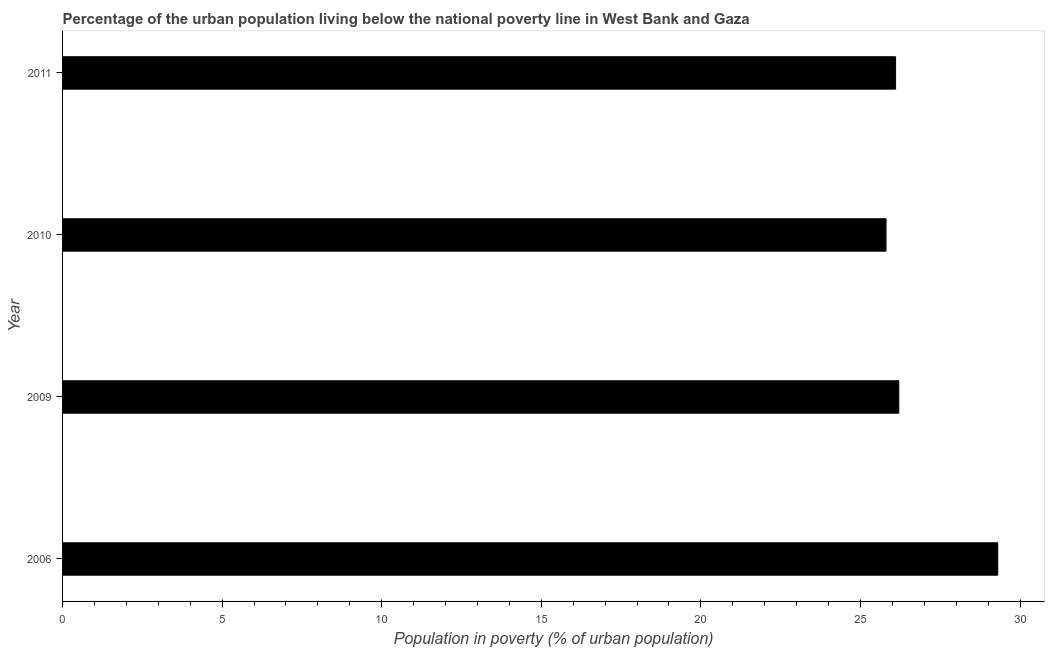Does the graph contain any zero values?
Offer a terse response. No. Does the graph contain grids?
Your answer should be compact. No. What is the title of the graph?
Your response must be concise. Percentage of the urban population living below the national poverty line in West Bank and Gaza. What is the label or title of the X-axis?
Give a very brief answer. Population in poverty (% of urban population). What is the label or title of the Y-axis?
Make the answer very short. Year. What is the percentage of urban population living below poverty line in 2009?
Provide a succinct answer. 26.2. Across all years, what is the maximum percentage of urban population living below poverty line?
Make the answer very short. 29.3. Across all years, what is the minimum percentage of urban population living below poverty line?
Your answer should be compact. 25.8. In which year was the percentage of urban population living below poverty line minimum?
Make the answer very short. 2010. What is the sum of the percentage of urban population living below poverty line?
Your answer should be compact. 107.4. What is the difference between the percentage of urban population living below poverty line in 2010 and 2011?
Provide a succinct answer. -0.3. What is the average percentage of urban population living below poverty line per year?
Give a very brief answer. 26.85. What is the median percentage of urban population living below poverty line?
Ensure brevity in your answer.  26.15. What is the ratio of the percentage of urban population living below poverty line in 2006 to that in 2010?
Offer a terse response. 1.14. What is the difference between the highest and the second highest percentage of urban population living below poverty line?
Give a very brief answer. 3.1. What is the difference between the highest and the lowest percentage of urban population living below poverty line?
Your answer should be compact. 3.5. In how many years, is the percentage of urban population living below poverty line greater than the average percentage of urban population living below poverty line taken over all years?
Provide a short and direct response. 1. How many years are there in the graph?
Keep it short and to the point. 4. What is the difference between two consecutive major ticks on the X-axis?
Give a very brief answer. 5. Are the values on the major ticks of X-axis written in scientific E-notation?
Your response must be concise. No. What is the Population in poverty (% of urban population) of 2006?
Your answer should be compact. 29.3. What is the Population in poverty (% of urban population) in 2009?
Your answer should be very brief. 26.2. What is the Population in poverty (% of urban population) in 2010?
Your answer should be very brief. 25.8. What is the Population in poverty (% of urban population) of 2011?
Your response must be concise. 26.1. What is the difference between the Population in poverty (% of urban population) in 2006 and 2010?
Provide a succinct answer. 3.5. What is the difference between the Population in poverty (% of urban population) in 2006 and 2011?
Offer a terse response. 3.2. What is the difference between the Population in poverty (% of urban population) in 2009 and 2010?
Ensure brevity in your answer.  0.4. What is the difference between the Population in poverty (% of urban population) in 2010 and 2011?
Offer a terse response. -0.3. What is the ratio of the Population in poverty (% of urban population) in 2006 to that in 2009?
Provide a short and direct response. 1.12. What is the ratio of the Population in poverty (% of urban population) in 2006 to that in 2010?
Keep it short and to the point. 1.14. What is the ratio of the Population in poverty (% of urban population) in 2006 to that in 2011?
Your answer should be very brief. 1.12. What is the ratio of the Population in poverty (% of urban population) in 2010 to that in 2011?
Give a very brief answer. 0.99. 